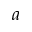Convert formula to latex. <formula><loc_0><loc_0><loc_500><loc_500>^ { a }</formula> 